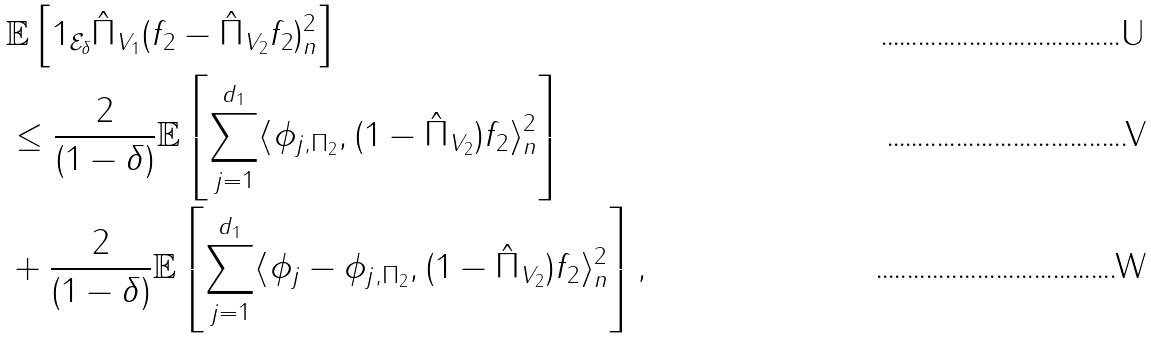Convert formula to latex. <formula><loc_0><loc_0><loc_500><loc_500>& \mathbb { E } \left [ 1 _ { \mathcal { E } _ { \delta } } \| \hat { \Pi } _ { V _ { 1 } } ( f _ { 2 } - \hat { \Pi } _ { V _ { 2 } } f _ { 2 } ) \| _ { n } ^ { 2 } \right ] \\ & \leq \frac { 2 } { ( 1 - \delta ) } \mathbb { E } \left [ \sum _ { j = 1 } ^ { d _ { 1 } } \langle \phi _ { j , \Pi _ { 2 } } , ( 1 - \hat { \Pi } _ { V _ { 2 } } ) f _ { 2 } \rangle _ { n } ^ { 2 } \right ] \\ & + \frac { 2 } { ( 1 - \delta ) } \mathbb { E } \left [ \sum _ { j = 1 } ^ { d _ { 1 } } \langle \phi _ { j } - \phi _ { j , \Pi _ { 2 } } , ( 1 - \hat { \Pi } _ { V _ { 2 } } ) f _ { 2 } \rangle _ { n } ^ { 2 } \right ] ,</formula> 